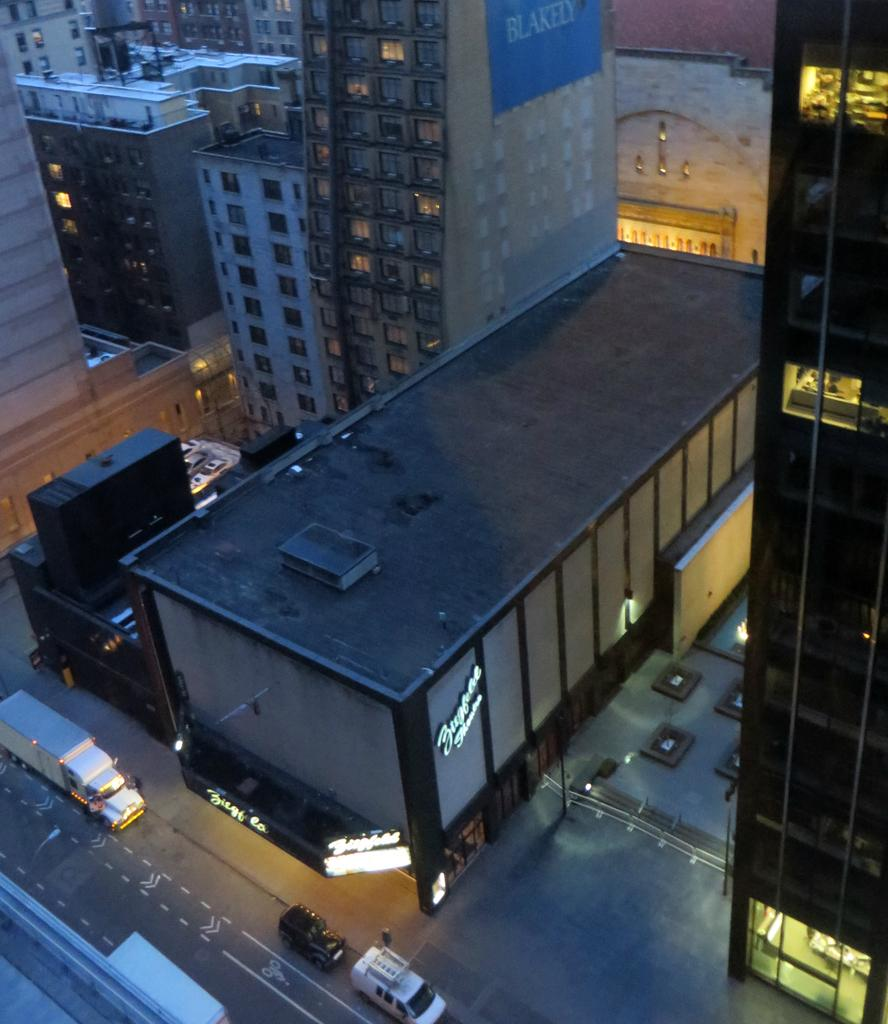What type of view is shown in the image? The image shows an aerial view of buildings. What kind of buildings can be seen in the image? There are tower buildings with many floors in the image. What can be seen between the buildings? Roads are visible between the buildings. What is moving on the roads? Vehicles are present on the roads. What type of pan is visible on the roof of the tallest building in the image? There is no pan visible on the roof of any building in the image. 